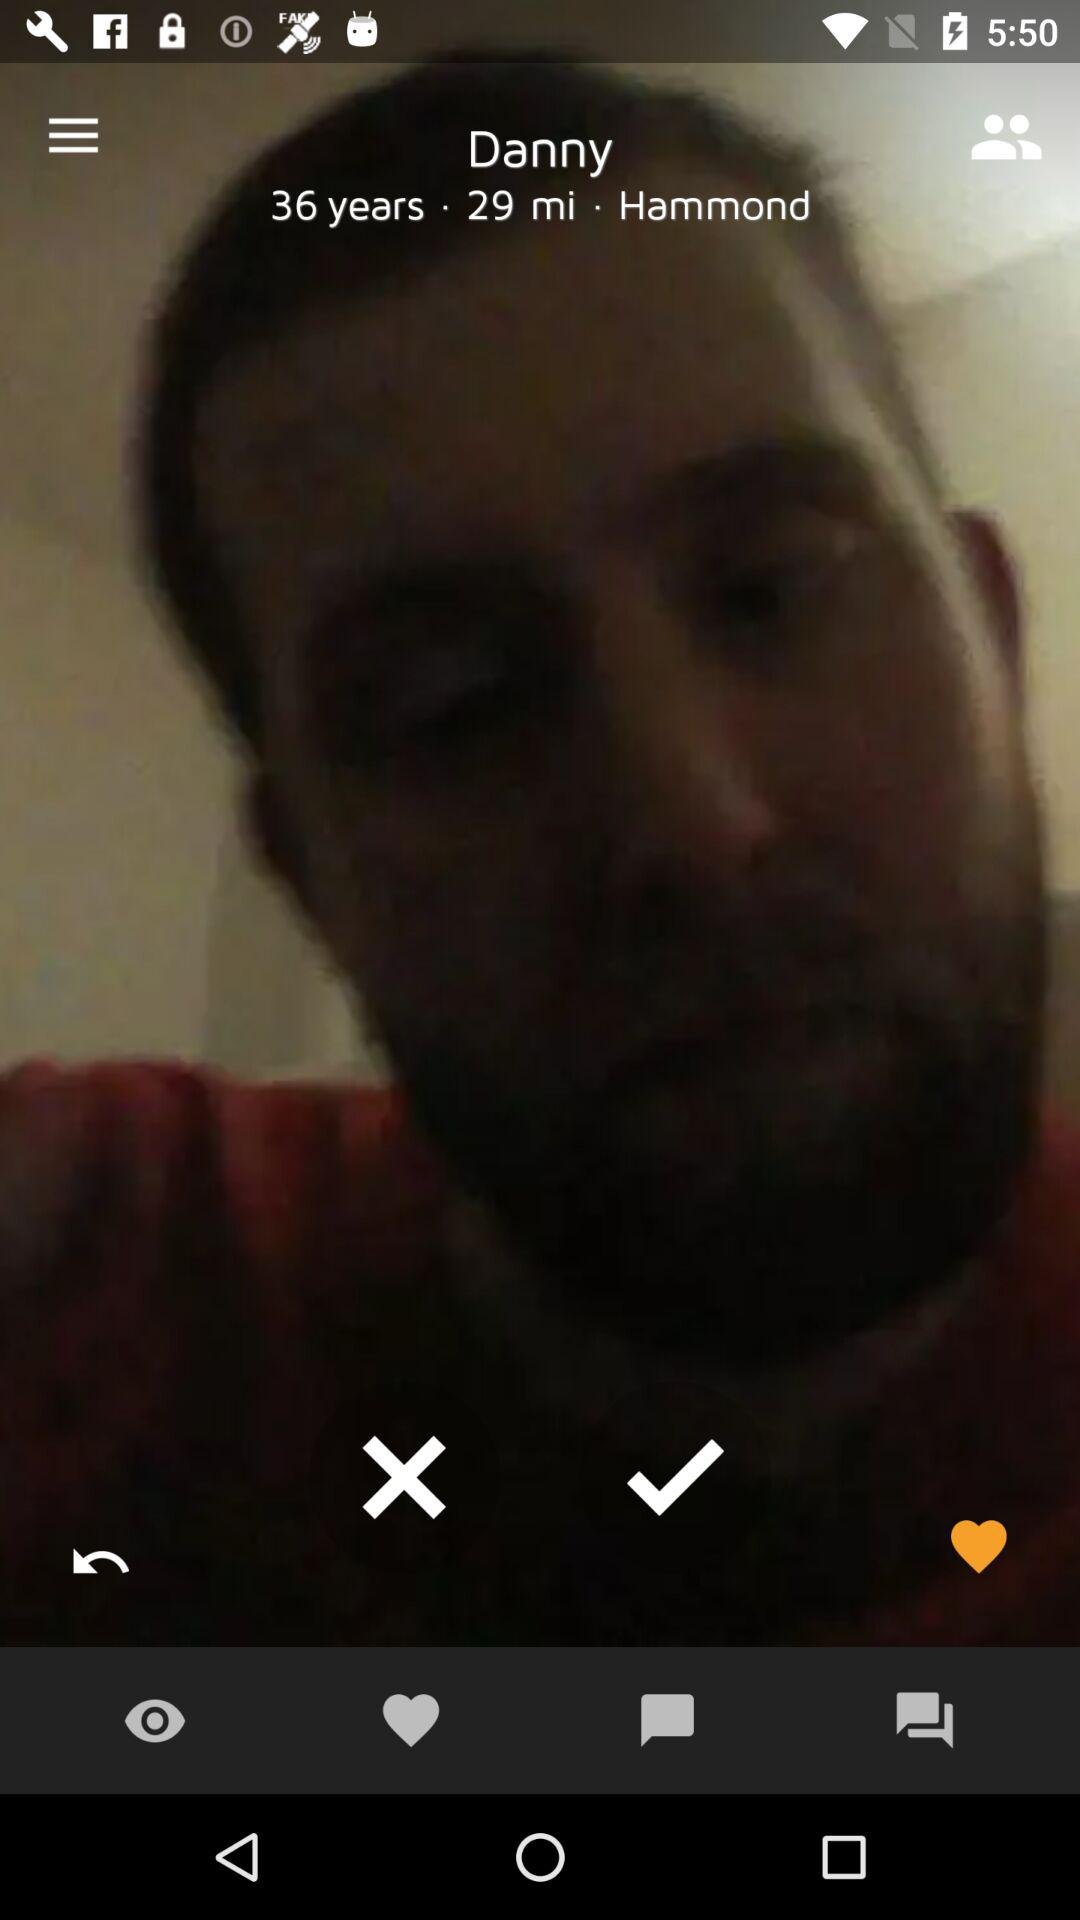What is the age of the user? The age of the user is 36 years. 